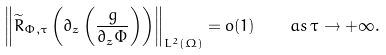<formula> <loc_0><loc_0><loc_500><loc_500>\left \| \widetilde { R } _ { \Phi , \tau } \left ( \partial _ { z } \left ( \frac { g } { \partial _ { z } \Phi } \right ) \right ) \right \| _ { L ^ { 2 } ( \Omega ) } = o ( 1 ) \quad a s \, \tau \rightarrow + \infty .</formula> 